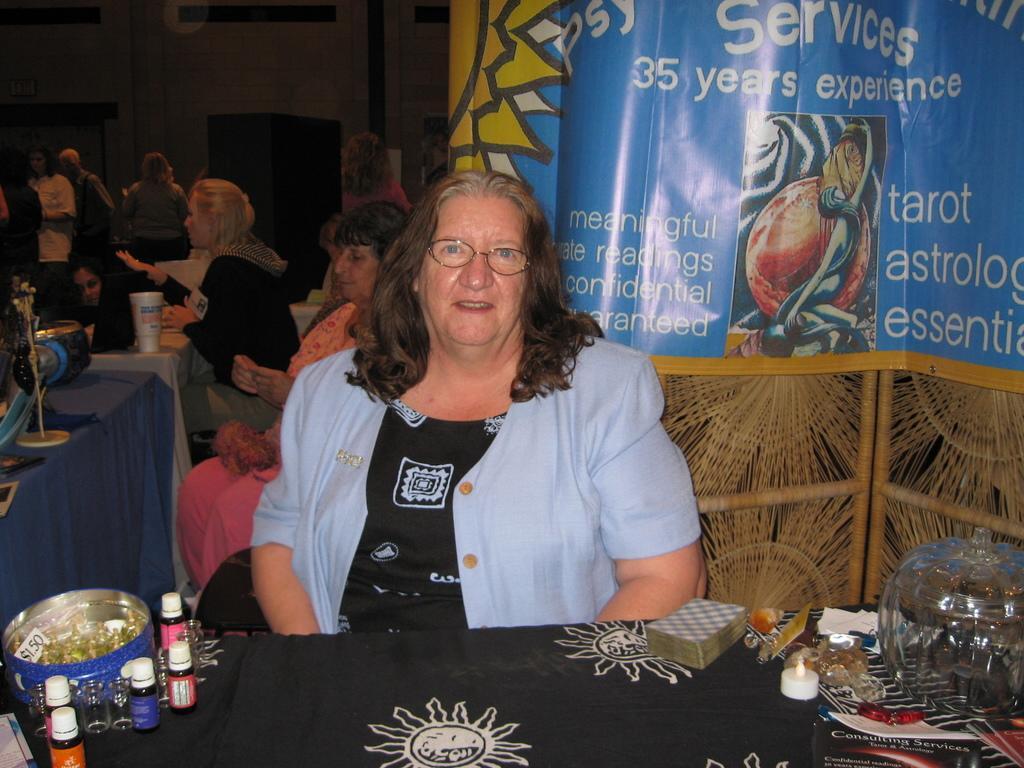Please provide a concise description of this image. In the image I can see a lady who is wearing jacket and sitting in front of the table on which there are some bottles and some other things and behind there are some other people and a poster to the side. 